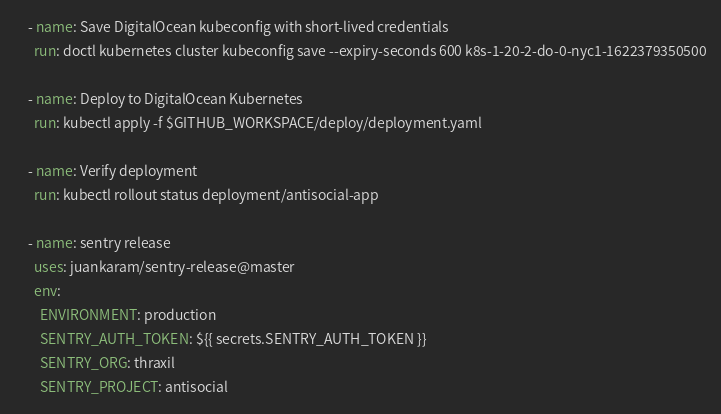<code> <loc_0><loc_0><loc_500><loc_500><_YAML_>    - name: Save DigitalOcean kubeconfig with short-lived credentials
      run: doctl kubernetes cluster kubeconfig save --expiry-seconds 600 k8s-1-20-2-do-0-nyc1-1622379350500

    - name: Deploy to DigitalOcean Kubernetes
      run: kubectl apply -f $GITHUB_WORKSPACE/deploy/deployment.yaml

    - name: Verify deployment
      run: kubectl rollout status deployment/antisocial-app

    - name: sentry release
      uses: juankaram/sentry-release@master
      env:
        ENVIRONMENT: production
        SENTRY_AUTH_TOKEN: ${{ secrets.SENTRY_AUTH_TOKEN }}
        SENTRY_ORG: thraxil
        SENTRY_PROJECT: antisocial
</code> 